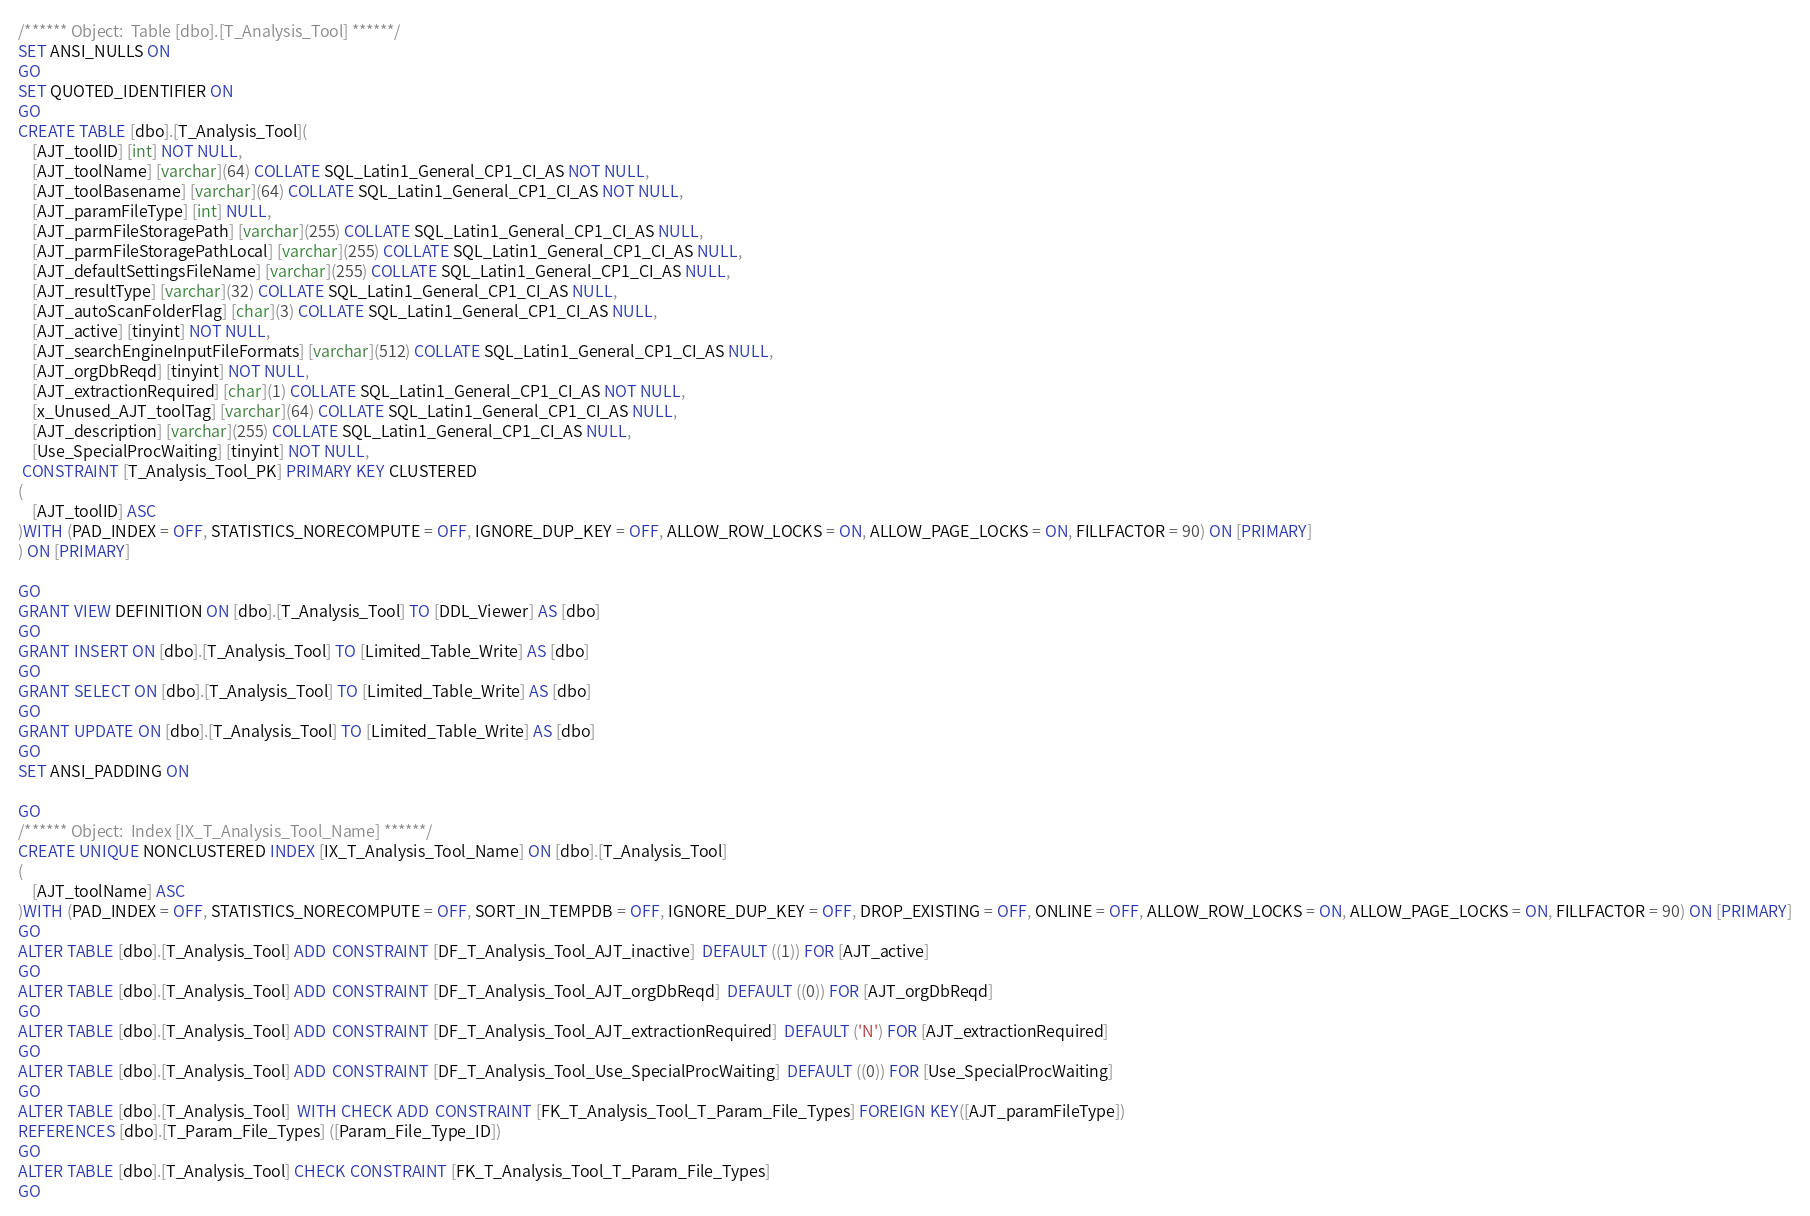<code> <loc_0><loc_0><loc_500><loc_500><_SQL_>/****** Object:  Table [dbo].[T_Analysis_Tool] ******/
SET ANSI_NULLS ON
GO
SET QUOTED_IDENTIFIER ON
GO
CREATE TABLE [dbo].[T_Analysis_Tool](
	[AJT_toolID] [int] NOT NULL,
	[AJT_toolName] [varchar](64) COLLATE SQL_Latin1_General_CP1_CI_AS NOT NULL,
	[AJT_toolBasename] [varchar](64) COLLATE SQL_Latin1_General_CP1_CI_AS NOT NULL,
	[AJT_paramFileType] [int] NULL,
	[AJT_parmFileStoragePath] [varchar](255) COLLATE SQL_Latin1_General_CP1_CI_AS NULL,
	[AJT_parmFileStoragePathLocal] [varchar](255) COLLATE SQL_Latin1_General_CP1_CI_AS NULL,
	[AJT_defaultSettingsFileName] [varchar](255) COLLATE SQL_Latin1_General_CP1_CI_AS NULL,
	[AJT_resultType] [varchar](32) COLLATE SQL_Latin1_General_CP1_CI_AS NULL,
	[AJT_autoScanFolderFlag] [char](3) COLLATE SQL_Latin1_General_CP1_CI_AS NULL,
	[AJT_active] [tinyint] NOT NULL,
	[AJT_searchEngineInputFileFormats] [varchar](512) COLLATE SQL_Latin1_General_CP1_CI_AS NULL,
	[AJT_orgDbReqd] [tinyint] NOT NULL,
	[AJT_extractionRequired] [char](1) COLLATE SQL_Latin1_General_CP1_CI_AS NOT NULL,
	[x_Unused_AJT_toolTag] [varchar](64) COLLATE SQL_Latin1_General_CP1_CI_AS NULL,
	[AJT_description] [varchar](255) COLLATE SQL_Latin1_General_CP1_CI_AS NULL,
	[Use_SpecialProcWaiting] [tinyint] NOT NULL,
 CONSTRAINT [T_Analysis_Tool_PK] PRIMARY KEY CLUSTERED 
(
	[AJT_toolID] ASC
)WITH (PAD_INDEX = OFF, STATISTICS_NORECOMPUTE = OFF, IGNORE_DUP_KEY = OFF, ALLOW_ROW_LOCKS = ON, ALLOW_PAGE_LOCKS = ON, FILLFACTOR = 90) ON [PRIMARY]
) ON [PRIMARY]

GO
GRANT VIEW DEFINITION ON [dbo].[T_Analysis_Tool] TO [DDL_Viewer] AS [dbo]
GO
GRANT INSERT ON [dbo].[T_Analysis_Tool] TO [Limited_Table_Write] AS [dbo]
GO
GRANT SELECT ON [dbo].[T_Analysis_Tool] TO [Limited_Table_Write] AS [dbo]
GO
GRANT UPDATE ON [dbo].[T_Analysis_Tool] TO [Limited_Table_Write] AS [dbo]
GO
SET ANSI_PADDING ON

GO
/****** Object:  Index [IX_T_Analysis_Tool_Name] ******/
CREATE UNIQUE NONCLUSTERED INDEX [IX_T_Analysis_Tool_Name] ON [dbo].[T_Analysis_Tool]
(
	[AJT_toolName] ASC
)WITH (PAD_INDEX = OFF, STATISTICS_NORECOMPUTE = OFF, SORT_IN_TEMPDB = OFF, IGNORE_DUP_KEY = OFF, DROP_EXISTING = OFF, ONLINE = OFF, ALLOW_ROW_LOCKS = ON, ALLOW_PAGE_LOCKS = ON, FILLFACTOR = 90) ON [PRIMARY]
GO
ALTER TABLE [dbo].[T_Analysis_Tool] ADD  CONSTRAINT [DF_T_Analysis_Tool_AJT_inactive]  DEFAULT ((1)) FOR [AJT_active]
GO
ALTER TABLE [dbo].[T_Analysis_Tool] ADD  CONSTRAINT [DF_T_Analysis_Tool_AJT_orgDbReqd]  DEFAULT ((0)) FOR [AJT_orgDbReqd]
GO
ALTER TABLE [dbo].[T_Analysis_Tool] ADD  CONSTRAINT [DF_T_Analysis_Tool_AJT_extractionRequired]  DEFAULT ('N') FOR [AJT_extractionRequired]
GO
ALTER TABLE [dbo].[T_Analysis_Tool] ADD  CONSTRAINT [DF_T_Analysis_Tool_Use_SpecialProcWaiting]  DEFAULT ((0)) FOR [Use_SpecialProcWaiting]
GO
ALTER TABLE [dbo].[T_Analysis_Tool]  WITH CHECK ADD  CONSTRAINT [FK_T_Analysis_Tool_T_Param_File_Types] FOREIGN KEY([AJT_paramFileType])
REFERENCES [dbo].[T_Param_File_Types] ([Param_File_Type_ID])
GO
ALTER TABLE [dbo].[T_Analysis_Tool] CHECK CONSTRAINT [FK_T_Analysis_Tool_T_Param_File_Types]
GO
</code> 